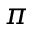<formula> <loc_0><loc_0><loc_500><loc_500>{ \boldsymbol \pi }</formula> 